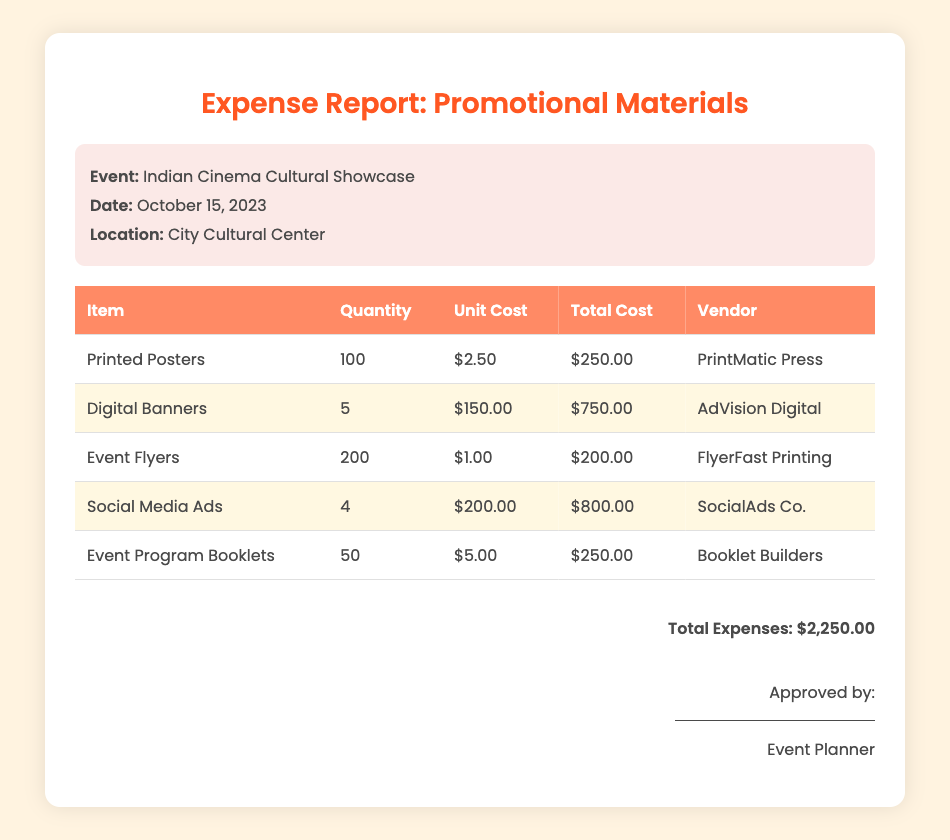what is the total cost for printed posters? The total cost for printed posters is listed in the table under Total Cost, which is $250.00.
Answer: $250.00 who is the vendor for digital banners? The vendor for digital banners can be found in the Vendor column of the table, which is AdVision Digital.
Answer: AdVision Digital how many social media ads were purchased? The quantity of social media ads is indicated in the Quantity column of the table, which is 4.
Answer: 4 what was the unit cost of event program booklets? The unit cost of event program booklets is shown in the Unit Cost column of the table, which is $5.00.
Answer: $5.00 what is the total expense amount? The total expense amount is listed at the bottom of the document, which sums up all costs, totaling $2,250.00.
Answer: $2,250.00 which item had the highest total cost? The item with the highest total cost is identified by comparing the Total Cost column, which is Digital Banners at $750.00.
Answer: Digital Banners when did the event take place? The event date is provided in the event details section of the document, which is October 15, 2023.
Answer: October 15, 2023 how many event flyers were printed? The number of event flyers printed is detailed in the Quantity column of the table, which indicates 200 flyers.
Answer: 200 who approved the expense report? The approver is mentioned in the signature section of the document, which states Event Planner.
Answer: Event Planner 